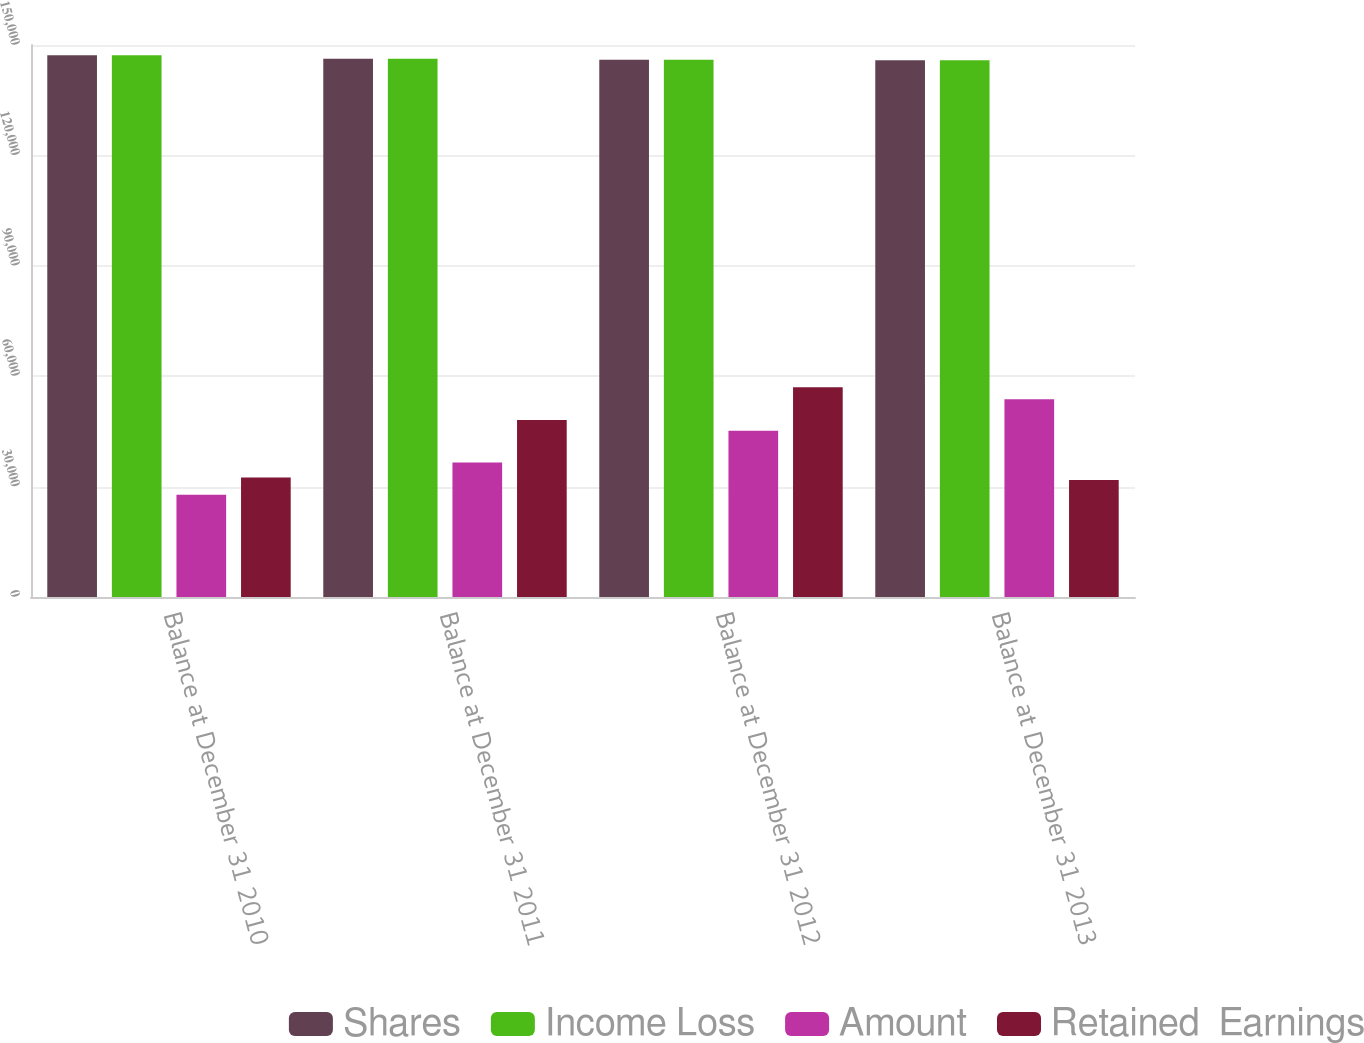Convert chart to OTSL. <chart><loc_0><loc_0><loc_500><loc_500><stacked_bar_chart><ecel><fcel>Balance at December 31 2010<fcel>Balance at December 31 2011<fcel>Balance at December 31 2012<fcel>Balance at December 31 2013<nl><fcel>Shares<fcel>147181<fcel>146251<fcel>146015<fcel>145864<nl><fcel>Income Loss<fcel>147181<fcel>146251<fcel>146015<fcel>145864<nl><fcel>Amount<fcel>27816<fcel>36554<fcel>45156<fcel>53765<nl><fcel>Retained  Earnings<fcel>32490<fcel>48090<fcel>56967<fcel>31771<nl></chart> 